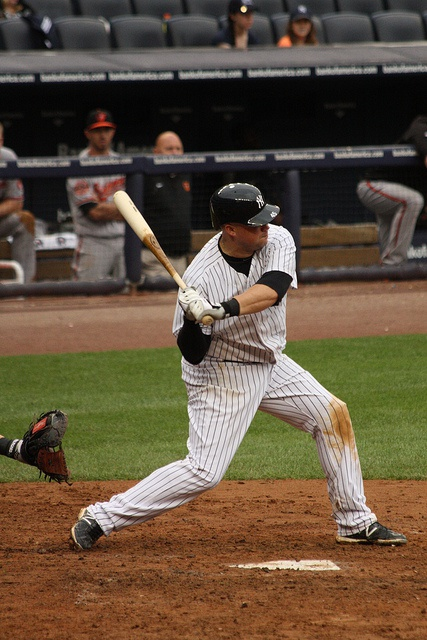Describe the objects in this image and their specific colors. I can see people in black, lightgray, darkgray, and gray tones, people in black, gray, and maroon tones, bench in black, maroon, and gray tones, people in black, gray, and maroon tones, and people in black, gray, darkgray, and maroon tones in this image. 